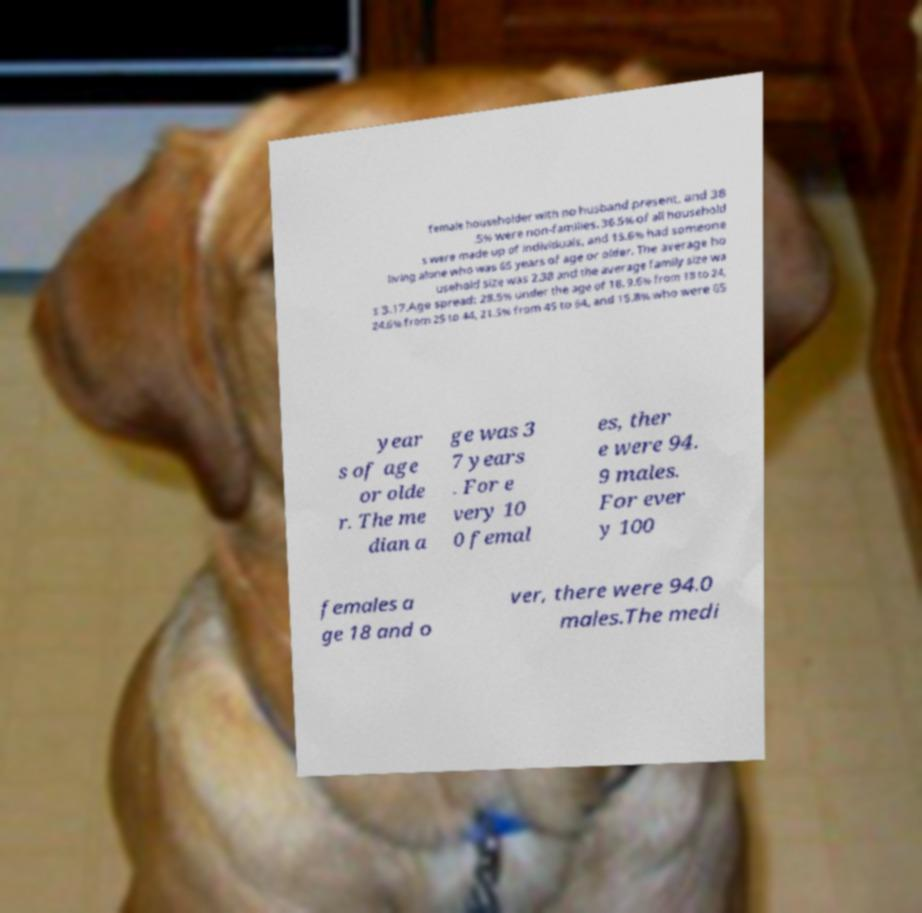I need the written content from this picture converted into text. Can you do that? female householder with no husband present, and 38 .5% were non-families. 36.5% of all household s were made up of individuals, and 15.6% had someone living alone who was 65 years of age or older. The average ho usehold size was 2.38 and the average family size wa s 3.17.Age spread: 28.5% under the age of 18, 9.6% from 18 to 24, 24.6% from 25 to 44, 21.5% from 45 to 64, and 15.8% who were 65 year s of age or olde r. The me dian a ge was 3 7 years . For e very 10 0 femal es, ther e were 94. 9 males. For ever y 100 females a ge 18 and o ver, there were 94.0 males.The medi 